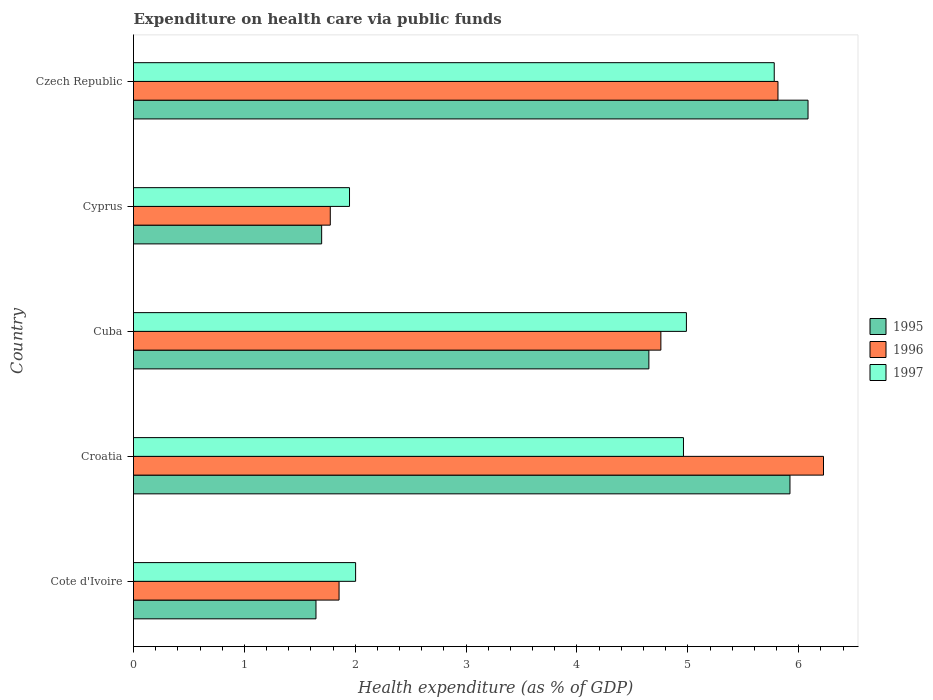How many different coloured bars are there?
Provide a succinct answer. 3. Are the number of bars per tick equal to the number of legend labels?
Offer a very short reply. Yes. Are the number of bars on each tick of the Y-axis equal?
Offer a terse response. Yes. What is the label of the 5th group of bars from the top?
Provide a succinct answer. Cote d'Ivoire. In how many cases, is the number of bars for a given country not equal to the number of legend labels?
Your response must be concise. 0. What is the expenditure made on health care in 1997 in Croatia?
Your answer should be very brief. 4.96. Across all countries, what is the maximum expenditure made on health care in 1996?
Offer a terse response. 6.22. Across all countries, what is the minimum expenditure made on health care in 1997?
Give a very brief answer. 1.95. In which country was the expenditure made on health care in 1995 maximum?
Give a very brief answer. Czech Republic. In which country was the expenditure made on health care in 1995 minimum?
Offer a very short reply. Cote d'Ivoire. What is the total expenditure made on health care in 1997 in the graph?
Make the answer very short. 19.68. What is the difference between the expenditure made on health care in 1995 in Croatia and that in Czech Republic?
Keep it short and to the point. -0.16. What is the difference between the expenditure made on health care in 1995 in Croatia and the expenditure made on health care in 1997 in Cyprus?
Keep it short and to the point. 3.97. What is the average expenditure made on health care in 1996 per country?
Give a very brief answer. 4.08. What is the difference between the expenditure made on health care in 1997 and expenditure made on health care in 1995 in Croatia?
Provide a succinct answer. -0.96. What is the ratio of the expenditure made on health care in 1995 in Cuba to that in Czech Republic?
Provide a short and direct response. 0.76. Is the expenditure made on health care in 1996 in Croatia less than that in Cyprus?
Offer a terse response. No. What is the difference between the highest and the second highest expenditure made on health care in 1996?
Make the answer very short. 0.41. What is the difference between the highest and the lowest expenditure made on health care in 1996?
Provide a short and direct response. 4.45. In how many countries, is the expenditure made on health care in 1997 greater than the average expenditure made on health care in 1997 taken over all countries?
Make the answer very short. 3. Is the sum of the expenditure made on health care in 1995 in Croatia and Cuba greater than the maximum expenditure made on health care in 1996 across all countries?
Ensure brevity in your answer.  Yes. Is it the case that in every country, the sum of the expenditure made on health care in 1995 and expenditure made on health care in 1997 is greater than the expenditure made on health care in 1996?
Your response must be concise. Yes. How many bars are there?
Make the answer very short. 15. Are all the bars in the graph horizontal?
Your response must be concise. Yes. How many countries are there in the graph?
Make the answer very short. 5. What is the difference between two consecutive major ticks on the X-axis?
Your answer should be compact. 1. Does the graph contain grids?
Your answer should be very brief. No. Where does the legend appear in the graph?
Your answer should be compact. Center right. How many legend labels are there?
Keep it short and to the point. 3. What is the title of the graph?
Your response must be concise. Expenditure on health care via public funds. What is the label or title of the X-axis?
Give a very brief answer. Health expenditure (as % of GDP). What is the Health expenditure (as % of GDP) in 1995 in Cote d'Ivoire?
Ensure brevity in your answer.  1.65. What is the Health expenditure (as % of GDP) in 1996 in Cote d'Ivoire?
Make the answer very short. 1.85. What is the Health expenditure (as % of GDP) in 1997 in Cote d'Ivoire?
Ensure brevity in your answer.  2. What is the Health expenditure (as % of GDP) of 1995 in Croatia?
Provide a succinct answer. 5.92. What is the Health expenditure (as % of GDP) of 1996 in Croatia?
Provide a short and direct response. 6.22. What is the Health expenditure (as % of GDP) of 1997 in Croatia?
Your answer should be very brief. 4.96. What is the Health expenditure (as % of GDP) in 1995 in Cuba?
Keep it short and to the point. 4.65. What is the Health expenditure (as % of GDP) of 1996 in Cuba?
Ensure brevity in your answer.  4.76. What is the Health expenditure (as % of GDP) in 1997 in Cuba?
Provide a short and direct response. 4.99. What is the Health expenditure (as % of GDP) of 1995 in Cyprus?
Offer a very short reply. 1.7. What is the Health expenditure (as % of GDP) in 1996 in Cyprus?
Provide a succinct answer. 1.77. What is the Health expenditure (as % of GDP) in 1997 in Cyprus?
Provide a short and direct response. 1.95. What is the Health expenditure (as % of GDP) in 1995 in Czech Republic?
Your response must be concise. 6.08. What is the Health expenditure (as % of GDP) of 1996 in Czech Republic?
Your answer should be compact. 5.81. What is the Health expenditure (as % of GDP) in 1997 in Czech Republic?
Your response must be concise. 5.78. Across all countries, what is the maximum Health expenditure (as % of GDP) of 1995?
Your response must be concise. 6.08. Across all countries, what is the maximum Health expenditure (as % of GDP) in 1996?
Your response must be concise. 6.22. Across all countries, what is the maximum Health expenditure (as % of GDP) of 1997?
Your answer should be very brief. 5.78. Across all countries, what is the minimum Health expenditure (as % of GDP) in 1995?
Ensure brevity in your answer.  1.65. Across all countries, what is the minimum Health expenditure (as % of GDP) in 1996?
Offer a very short reply. 1.77. Across all countries, what is the minimum Health expenditure (as % of GDP) in 1997?
Ensure brevity in your answer.  1.95. What is the total Health expenditure (as % of GDP) of 1995 in the graph?
Keep it short and to the point. 20. What is the total Health expenditure (as % of GDP) in 1996 in the graph?
Give a very brief answer. 20.42. What is the total Health expenditure (as % of GDP) of 1997 in the graph?
Provide a short and direct response. 19.68. What is the difference between the Health expenditure (as % of GDP) of 1995 in Cote d'Ivoire and that in Croatia?
Your answer should be compact. -4.28. What is the difference between the Health expenditure (as % of GDP) of 1996 in Cote d'Ivoire and that in Croatia?
Make the answer very short. -4.37. What is the difference between the Health expenditure (as % of GDP) of 1997 in Cote d'Ivoire and that in Croatia?
Your answer should be compact. -2.96. What is the difference between the Health expenditure (as % of GDP) of 1995 in Cote d'Ivoire and that in Cuba?
Provide a short and direct response. -3. What is the difference between the Health expenditure (as % of GDP) in 1996 in Cote d'Ivoire and that in Cuba?
Your response must be concise. -2.9. What is the difference between the Health expenditure (as % of GDP) of 1997 in Cote d'Ivoire and that in Cuba?
Make the answer very short. -2.98. What is the difference between the Health expenditure (as % of GDP) in 1995 in Cote d'Ivoire and that in Cyprus?
Keep it short and to the point. -0.05. What is the difference between the Health expenditure (as % of GDP) of 1996 in Cote d'Ivoire and that in Cyprus?
Give a very brief answer. 0.08. What is the difference between the Health expenditure (as % of GDP) in 1997 in Cote d'Ivoire and that in Cyprus?
Offer a terse response. 0.05. What is the difference between the Health expenditure (as % of GDP) of 1995 in Cote d'Ivoire and that in Czech Republic?
Make the answer very short. -4.44. What is the difference between the Health expenditure (as % of GDP) in 1996 in Cote d'Ivoire and that in Czech Republic?
Offer a very short reply. -3.96. What is the difference between the Health expenditure (as % of GDP) in 1997 in Cote d'Ivoire and that in Czech Republic?
Give a very brief answer. -3.78. What is the difference between the Health expenditure (as % of GDP) in 1995 in Croatia and that in Cuba?
Provide a short and direct response. 1.27. What is the difference between the Health expenditure (as % of GDP) of 1996 in Croatia and that in Cuba?
Ensure brevity in your answer.  1.47. What is the difference between the Health expenditure (as % of GDP) of 1997 in Croatia and that in Cuba?
Your answer should be very brief. -0.03. What is the difference between the Health expenditure (as % of GDP) in 1995 in Croatia and that in Cyprus?
Keep it short and to the point. 4.22. What is the difference between the Health expenditure (as % of GDP) of 1996 in Croatia and that in Cyprus?
Your answer should be very brief. 4.45. What is the difference between the Health expenditure (as % of GDP) of 1997 in Croatia and that in Cyprus?
Give a very brief answer. 3.01. What is the difference between the Health expenditure (as % of GDP) of 1995 in Croatia and that in Czech Republic?
Your answer should be compact. -0.16. What is the difference between the Health expenditure (as % of GDP) in 1996 in Croatia and that in Czech Republic?
Give a very brief answer. 0.41. What is the difference between the Health expenditure (as % of GDP) in 1997 in Croatia and that in Czech Republic?
Provide a short and direct response. -0.82. What is the difference between the Health expenditure (as % of GDP) in 1995 in Cuba and that in Cyprus?
Provide a short and direct response. 2.95. What is the difference between the Health expenditure (as % of GDP) of 1996 in Cuba and that in Cyprus?
Offer a terse response. 2.98. What is the difference between the Health expenditure (as % of GDP) in 1997 in Cuba and that in Cyprus?
Provide a succinct answer. 3.04. What is the difference between the Health expenditure (as % of GDP) in 1995 in Cuba and that in Czech Republic?
Ensure brevity in your answer.  -1.44. What is the difference between the Health expenditure (as % of GDP) in 1996 in Cuba and that in Czech Republic?
Your answer should be compact. -1.06. What is the difference between the Health expenditure (as % of GDP) of 1997 in Cuba and that in Czech Republic?
Give a very brief answer. -0.79. What is the difference between the Health expenditure (as % of GDP) of 1995 in Cyprus and that in Czech Republic?
Give a very brief answer. -4.39. What is the difference between the Health expenditure (as % of GDP) in 1996 in Cyprus and that in Czech Republic?
Give a very brief answer. -4.04. What is the difference between the Health expenditure (as % of GDP) in 1997 in Cyprus and that in Czech Republic?
Keep it short and to the point. -3.83. What is the difference between the Health expenditure (as % of GDP) of 1995 in Cote d'Ivoire and the Health expenditure (as % of GDP) of 1996 in Croatia?
Your answer should be compact. -4.58. What is the difference between the Health expenditure (as % of GDP) of 1995 in Cote d'Ivoire and the Health expenditure (as % of GDP) of 1997 in Croatia?
Give a very brief answer. -3.31. What is the difference between the Health expenditure (as % of GDP) of 1996 in Cote d'Ivoire and the Health expenditure (as % of GDP) of 1997 in Croatia?
Your response must be concise. -3.11. What is the difference between the Health expenditure (as % of GDP) in 1995 in Cote d'Ivoire and the Health expenditure (as % of GDP) in 1996 in Cuba?
Give a very brief answer. -3.11. What is the difference between the Health expenditure (as % of GDP) in 1995 in Cote d'Ivoire and the Health expenditure (as % of GDP) in 1997 in Cuba?
Give a very brief answer. -3.34. What is the difference between the Health expenditure (as % of GDP) in 1996 in Cote d'Ivoire and the Health expenditure (as % of GDP) in 1997 in Cuba?
Your answer should be very brief. -3.13. What is the difference between the Health expenditure (as % of GDP) of 1995 in Cote d'Ivoire and the Health expenditure (as % of GDP) of 1996 in Cyprus?
Provide a succinct answer. -0.13. What is the difference between the Health expenditure (as % of GDP) of 1995 in Cote d'Ivoire and the Health expenditure (as % of GDP) of 1997 in Cyprus?
Your answer should be very brief. -0.3. What is the difference between the Health expenditure (as % of GDP) of 1996 in Cote d'Ivoire and the Health expenditure (as % of GDP) of 1997 in Cyprus?
Provide a short and direct response. -0.09. What is the difference between the Health expenditure (as % of GDP) of 1995 in Cote d'Ivoire and the Health expenditure (as % of GDP) of 1996 in Czech Republic?
Provide a short and direct response. -4.17. What is the difference between the Health expenditure (as % of GDP) of 1995 in Cote d'Ivoire and the Health expenditure (as % of GDP) of 1997 in Czech Republic?
Give a very brief answer. -4.13. What is the difference between the Health expenditure (as % of GDP) of 1996 in Cote d'Ivoire and the Health expenditure (as % of GDP) of 1997 in Czech Republic?
Your answer should be very brief. -3.93. What is the difference between the Health expenditure (as % of GDP) of 1995 in Croatia and the Health expenditure (as % of GDP) of 1996 in Cuba?
Provide a short and direct response. 1.16. What is the difference between the Health expenditure (as % of GDP) in 1995 in Croatia and the Health expenditure (as % of GDP) in 1997 in Cuba?
Your response must be concise. 0.93. What is the difference between the Health expenditure (as % of GDP) in 1996 in Croatia and the Health expenditure (as % of GDP) in 1997 in Cuba?
Offer a terse response. 1.24. What is the difference between the Health expenditure (as % of GDP) in 1995 in Croatia and the Health expenditure (as % of GDP) in 1996 in Cyprus?
Provide a short and direct response. 4.15. What is the difference between the Health expenditure (as % of GDP) of 1995 in Croatia and the Health expenditure (as % of GDP) of 1997 in Cyprus?
Your answer should be compact. 3.97. What is the difference between the Health expenditure (as % of GDP) in 1996 in Croatia and the Health expenditure (as % of GDP) in 1997 in Cyprus?
Provide a short and direct response. 4.28. What is the difference between the Health expenditure (as % of GDP) of 1995 in Croatia and the Health expenditure (as % of GDP) of 1996 in Czech Republic?
Provide a succinct answer. 0.11. What is the difference between the Health expenditure (as % of GDP) of 1995 in Croatia and the Health expenditure (as % of GDP) of 1997 in Czech Republic?
Keep it short and to the point. 0.14. What is the difference between the Health expenditure (as % of GDP) in 1996 in Croatia and the Health expenditure (as % of GDP) in 1997 in Czech Republic?
Keep it short and to the point. 0.44. What is the difference between the Health expenditure (as % of GDP) of 1995 in Cuba and the Health expenditure (as % of GDP) of 1996 in Cyprus?
Make the answer very short. 2.87. What is the difference between the Health expenditure (as % of GDP) in 1995 in Cuba and the Health expenditure (as % of GDP) in 1997 in Cyprus?
Offer a very short reply. 2.7. What is the difference between the Health expenditure (as % of GDP) of 1996 in Cuba and the Health expenditure (as % of GDP) of 1997 in Cyprus?
Your answer should be very brief. 2.81. What is the difference between the Health expenditure (as % of GDP) of 1995 in Cuba and the Health expenditure (as % of GDP) of 1996 in Czech Republic?
Offer a terse response. -1.16. What is the difference between the Health expenditure (as % of GDP) of 1995 in Cuba and the Health expenditure (as % of GDP) of 1997 in Czech Republic?
Provide a short and direct response. -1.13. What is the difference between the Health expenditure (as % of GDP) in 1996 in Cuba and the Health expenditure (as % of GDP) in 1997 in Czech Republic?
Your response must be concise. -1.02. What is the difference between the Health expenditure (as % of GDP) in 1995 in Cyprus and the Health expenditure (as % of GDP) in 1996 in Czech Republic?
Ensure brevity in your answer.  -4.12. What is the difference between the Health expenditure (as % of GDP) in 1995 in Cyprus and the Health expenditure (as % of GDP) in 1997 in Czech Republic?
Your answer should be very brief. -4.08. What is the difference between the Health expenditure (as % of GDP) of 1996 in Cyprus and the Health expenditure (as % of GDP) of 1997 in Czech Republic?
Your response must be concise. -4. What is the average Health expenditure (as % of GDP) of 1995 per country?
Your answer should be compact. 4. What is the average Health expenditure (as % of GDP) in 1996 per country?
Your answer should be very brief. 4.08. What is the average Health expenditure (as % of GDP) of 1997 per country?
Give a very brief answer. 3.94. What is the difference between the Health expenditure (as % of GDP) in 1995 and Health expenditure (as % of GDP) in 1996 in Cote d'Ivoire?
Ensure brevity in your answer.  -0.21. What is the difference between the Health expenditure (as % of GDP) in 1995 and Health expenditure (as % of GDP) in 1997 in Cote d'Ivoire?
Offer a terse response. -0.36. What is the difference between the Health expenditure (as % of GDP) in 1996 and Health expenditure (as % of GDP) in 1997 in Cote d'Ivoire?
Provide a short and direct response. -0.15. What is the difference between the Health expenditure (as % of GDP) in 1995 and Health expenditure (as % of GDP) in 1996 in Croatia?
Offer a very short reply. -0.3. What is the difference between the Health expenditure (as % of GDP) of 1995 and Health expenditure (as % of GDP) of 1997 in Croatia?
Your answer should be compact. 0.96. What is the difference between the Health expenditure (as % of GDP) in 1996 and Health expenditure (as % of GDP) in 1997 in Croatia?
Give a very brief answer. 1.26. What is the difference between the Health expenditure (as % of GDP) in 1995 and Health expenditure (as % of GDP) in 1996 in Cuba?
Provide a succinct answer. -0.11. What is the difference between the Health expenditure (as % of GDP) of 1995 and Health expenditure (as % of GDP) of 1997 in Cuba?
Give a very brief answer. -0.34. What is the difference between the Health expenditure (as % of GDP) of 1996 and Health expenditure (as % of GDP) of 1997 in Cuba?
Your answer should be very brief. -0.23. What is the difference between the Health expenditure (as % of GDP) in 1995 and Health expenditure (as % of GDP) in 1996 in Cyprus?
Make the answer very short. -0.08. What is the difference between the Health expenditure (as % of GDP) of 1995 and Health expenditure (as % of GDP) of 1997 in Cyprus?
Your answer should be very brief. -0.25. What is the difference between the Health expenditure (as % of GDP) in 1996 and Health expenditure (as % of GDP) in 1997 in Cyprus?
Your answer should be very brief. -0.17. What is the difference between the Health expenditure (as % of GDP) of 1995 and Health expenditure (as % of GDP) of 1996 in Czech Republic?
Your response must be concise. 0.27. What is the difference between the Health expenditure (as % of GDP) of 1995 and Health expenditure (as % of GDP) of 1997 in Czech Republic?
Provide a short and direct response. 0.3. What is the difference between the Health expenditure (as % of GDP) in 1996 and Health expenditure (as % of GDP) in 1997 in Czech Republic?
Offer a very short reply. 0.03. What is the ratio of the Health expenditure (as % of GDP) of 1995 in Cote d'Ivoire to that in Croatia?
Offer a very short reply. 0.28. What is the ratio of the Health expenditure (as % of GDP) in 1996 in Cote d'Ivoire to that in Croatia?
Keep it short and to the point. 0.3. What is the ratio of the Health expenditure (as % of GDP) of 1997 in Cote d'Ivoire to that in Croatia?
Provide a succinct answer. 0.4. What is the ratio of the Health expenditure (as % of GDP) in 1995 in Cote d'Ivoire to that in Cuba?
Offer a very short reply. 0.35. What is the ratio of the Health expenditure (as % of GDP) of 1996 in Cote d'Ivoire to that in Cuba?
Provide a short and direct response. 0.39. What is the ratio of the Health expenditure (as % of GDP) of 1997 in Cote d'Ivoire to that in Cuba?
Ensure brevity in your answer.  0.4. What is the ratio of the Health expenditure (as % of GDP) of 1995 in Cote d'Ivoire to that in Cyprus?
Make the answer very short. 0.97. What is the ratio of the Health expenditure (as % of GDP) of 1996 in Cote d'Ivoire to that in Cyprus?
Ensure brevity in your answer.  1.04. What is the ratio of the Health expenditure (as % of GDP) of 1997 in Cote d'Ivoire to that in Cyprus?
Your response must be concise. 1.03. What is the ratio of the Health expenditure (as % of GDP) of 1995 in Cote d'Ivoire to that in Czech Republic?
Offer a very short reply. 0.27. What is the ratio of the Health expenditure (as % of GDP) in 1996 in Cote d'Ivoire to that in Czech Republic?
Offer a terse response. 0.32. What is the ratio of the Health expenditure (as % of GDP) of 1997 in Cote d'Ivoire to that in Czech Republic?
Make the answer very short. 0.35. What is the ratio of the Health expenditure (as % of GDP) of 1995 in Croatia to that in Cuba?
Provide a succinct answer. 1.27. What is the ratio of the Health expenditure (as % of GDP) of 1996 in Croatia to that in Cuba?
Offer a terse response. 1.31. What is the ratio of the Health expenditure (as % of GDP) of 1997 in Croatia to that in Cuba?
Your answer should be compact. 0.99. What is the ratio of the Health expenditure (as % of GDP) in 1995 in Croatia to that in Cyprus?
Your answer should be very brief. 3.49. What is the ratio of the Health expenditure (as % of GDP) in 1996 in Croatia to that in Cyprus?
Your response must be concise. 3.51. What is the ratio of the Health expenditure (as % of GDP) of 1997 in Croatia to that in Cyprus?
Ensure brevity in your answer.  2.55. What is the ratio of the Health expenditure (as % of GDP) of 1995 in Croatia to that in Czech Republic?
Your answer should be compact. 0.97. What is the ratio of the Health expenditure (as % of GDP) in 1996 in Croatia to that in Czech Republic?
Make the answer very short. 1.07. What is the ratio of the Health expenditure (as % of GDP) of 1997 in Croatia to that in Czech Republic?
Your answer should be compact. 0.86. What is the ratio of the Health expenditure (as % of GDP) of 1995 in Cuba to that in Cyprus?
Your answer should be very brief. 2.74. What is the ratio of the Health expenditure (as % of GDP) of 1996 in Cuba to that in Cyprus?
Ensure brevity in your answer.  2.68. What is the ratio of the Health expenditure (as % of GDP) of 1997 in Cuba to that in Cyprus?
Ensure brevity in your answer.  2.56. What is the ratio of the Health expenditure (as % of GDP) in 1995 in Cuba to that in Czech Republic?
Give a very brief answer. 0.76. What is the ratio of the Health expenditure (as % of GDP) of 1996 in Cuba to that in Czech Republic?
Give a very brief answer. 0.82. What is the ratio of the Health expenditure (as % of GDP) in 1997 in Cuba to that in Czech Republic?
Provide a succinct answer. 0.86. What is the ratio of the Health expenditure (as % of GDP) of 1995 in Cyprus to that in Czech Republic?
Your response must be concise. 0.28. What is the ratio of the Health expenditure (as % of GDP) in 1996 in Cyprus to that in Czech Republic?
Offer a terse response. 0.31. What is the ratio of the Health expenditure (as % of GDP) of 1997 in Cyprus to that in Czech Republic?
Your response must be concise. 0.34. What is the difference between the highest and the second highest Health expenditure (as % of GDP) of 1995?
Provide a short and direct response. 0.16. What is the difference between the highest and the second highest Health expenditure (as % of GDP) of 1996?
Give a very brief answer. 0.41. What is the difference between the highest and the second highest Health expenditure (as % of GDP) of 1997?
Offer a terse response. 0.79. What is the difference between the highest and the lowest Health expenditure (as % of GDP) in 1995?
Your answer should be compact. 4.44. What is the difference between the highest and the lowest Health expenditure (as % of GDP) in 1996?
Ensure brevity in your answer.  4.45. What is the difference between the highest and the lowest Health expenditure (as % of GDP) of 1997?
Offer a terse response. 3.83. 